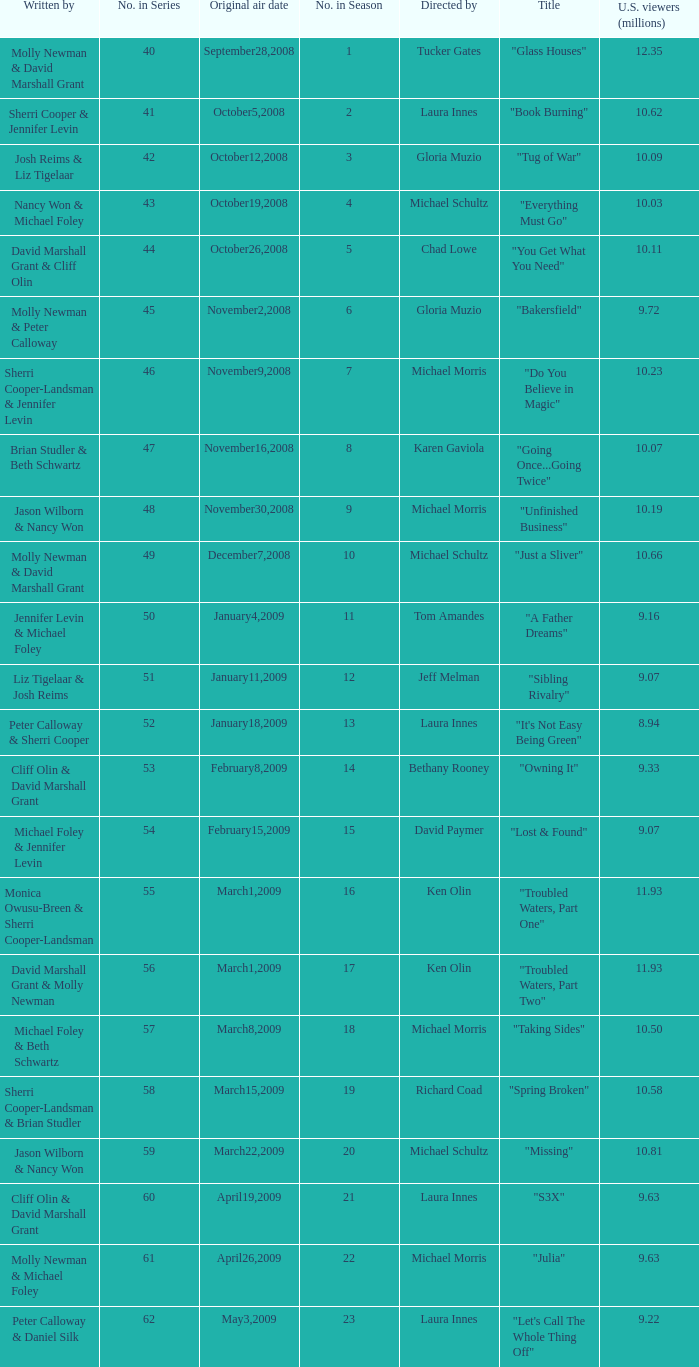When did the episode titled "Do you believe in magic" run for the first time? November9,2008. 